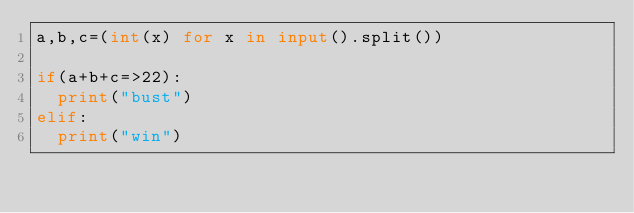<code> <loc_0><loc_0><loc_500><loc_500><_Python_>a,b,c=(int(x) for x in input().split())

if(a+b+c=>22):
  print("bust")
elif:
  print("win")</code> 